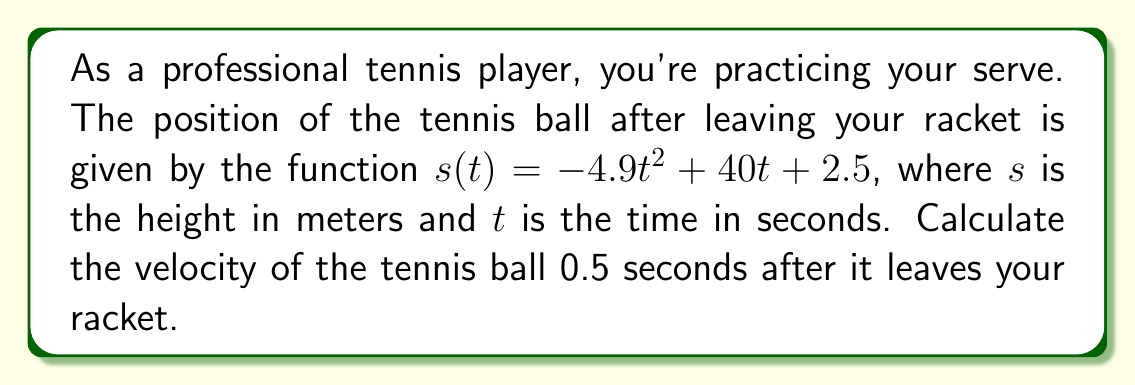Give your solution to this math problem. To solve this problem, we need to follow these steps:

1) The velocity of the ball is the first derivative of its position function. Let's call the velocity function $v(t)$.

2) To find $v(t)$, we need to differentiate $s(t)$ with respect to $t$:

   $s(t) = -4.9t^2 + 40t + 2.5$
   $v(t) = \frac{d}{dt}s(t) = -9.8t + 40$

3) Now that we have the velocity function, we need to calculate the velocity at $t = 0.5$ seconds:

   $v(0.5) = -9.8(0.5) + 40$
   $v(0.5) = -4.9 + 40$
   $v(0.5) = 35.1$

4) The units for velocity will be meters per second (m/s), as the original function gave height in meters and time in seconds.

Therefore, the velocity of the tennis ball 0.5 seconds after it leaves your racket is 35.1 m/s.
Answer: 35.1 m/s 